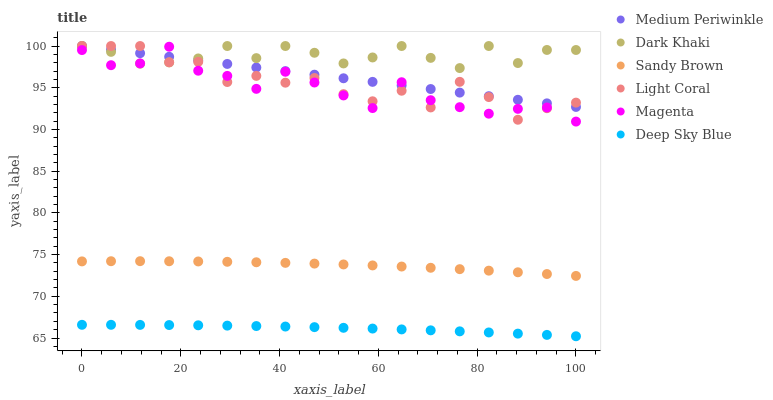Does Deep Sky Blue have the minimum area under the curve?
Answer yes or no. Yes. Does Dark Khaki have the maximum area under the curve?
Answer yes or no. Yes. Does Medium Periwinkle have the minimum area under the curve?
Answer yes or no. No. Does Medium Periwinkle have the maximum area under the curve?
Answer yes or no. No. Is Medium Periwinkle the smoothest?
Answer yes or no. Yes. Is Light Coral the roughest?
Answer yes or no. Yes. Is Dark Khaki the smoothest?
Answer yes or no. No. Is Dark Khaki the roughest?
Answer yes or no. No. Does Deep Sky Blue have the lowest value?
Answer yes or no. Yes. Does Medium Periwinkle have the lowest value?
Answer yes or no. No. Does Dark Khaki have the highest value?
Answer yes or no. Yes. Does Deep Sky Blue have the highest value?
Answer yes or no. No. Is Sandy Brown less than Dark Khaki?
Answer yes or no. Yes. Is Dark Khaki greater than Sandy Brown?
Answer yes or no. Yes. Does Dark Khaki intersect Medium Periwinkle?
Answer yes or no. Yes. Is Dark Khaki less than Medium Periwinkle?
Answer yes or no. No. Is Dark Khaki greater than Medium Periwinkle?
Answer yes or no. No. Does Sandy Brown intersect Dark Khaki?
Answer yes or no. No. 